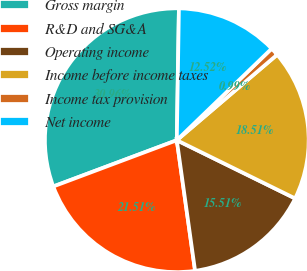Convert chart. <chart><loc_0><loc_0><loc_500><loc_500><pie_chart><fcel>Gross margin<fcel>R&D and SG&A<fcel>Operating income<fcel>Income before income taxes<fcel>Income tax provision<fcel>Net income<nl><fcel>30.96%<fcel>21.51%<fcel>15.51%<fcel>18.51%<fcel>0.99%<fcel>12.52%<nl></chart> 